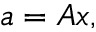<formula> <loc_0><loc_0><loc_500><loc_500>a = A x ,</formula> 